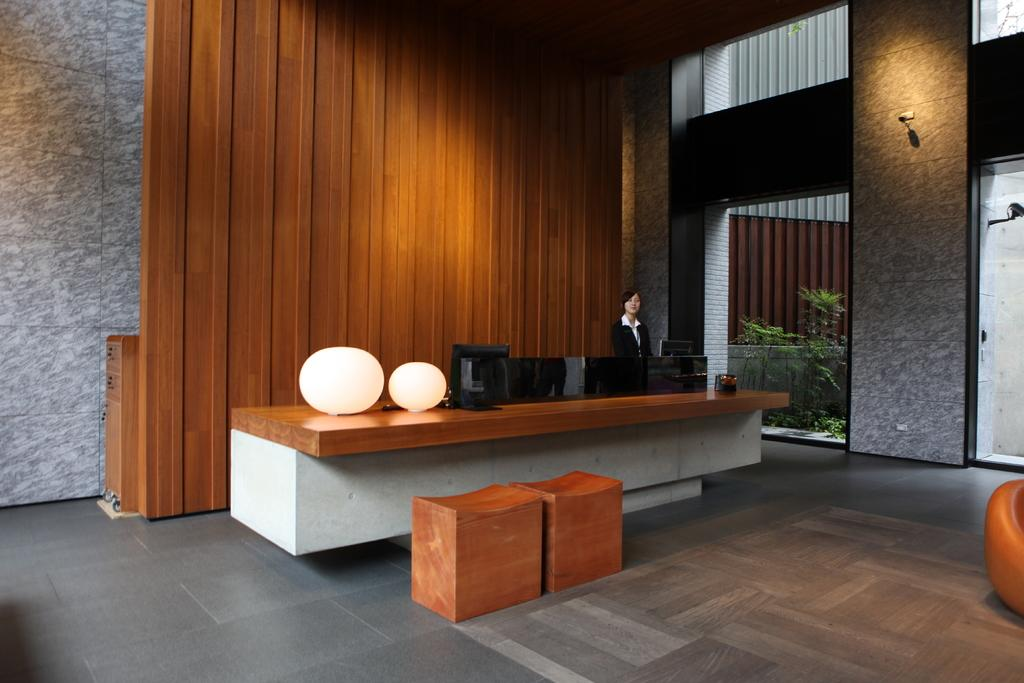What is the main subject in the image? There is a woman standing in the image. What can be seen behind the woman? There is a wall in the background of the image. What is present on the floor in the image? There are objects on the floor in the image. What else can be seen in the background of the image? There is a light and plants in the background of the image. What is the purpose of the monitors in the image? The purpose of the monitors is not specified, but they are visible in the image. What color is the milk being poured into the glass in the image? There is no milk or glass present in the image. 